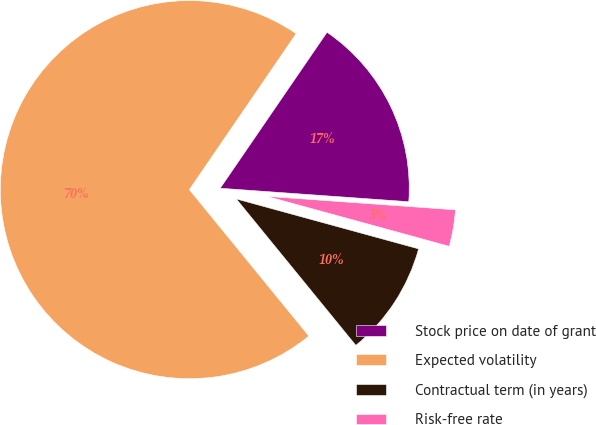Convert chart to OTSL. <chart><loc_0><loc_0><loc_500><loc_500><pie_chart><fcel>Stock price on date of grant<fcel>Expected volatility<fcel>Contractual term (in years)<fcel>Risk-free rate<nl><fcel>16.58%<fcel>70.46%<fcel>9.85%<fcel>3.12%<nl></chart> 